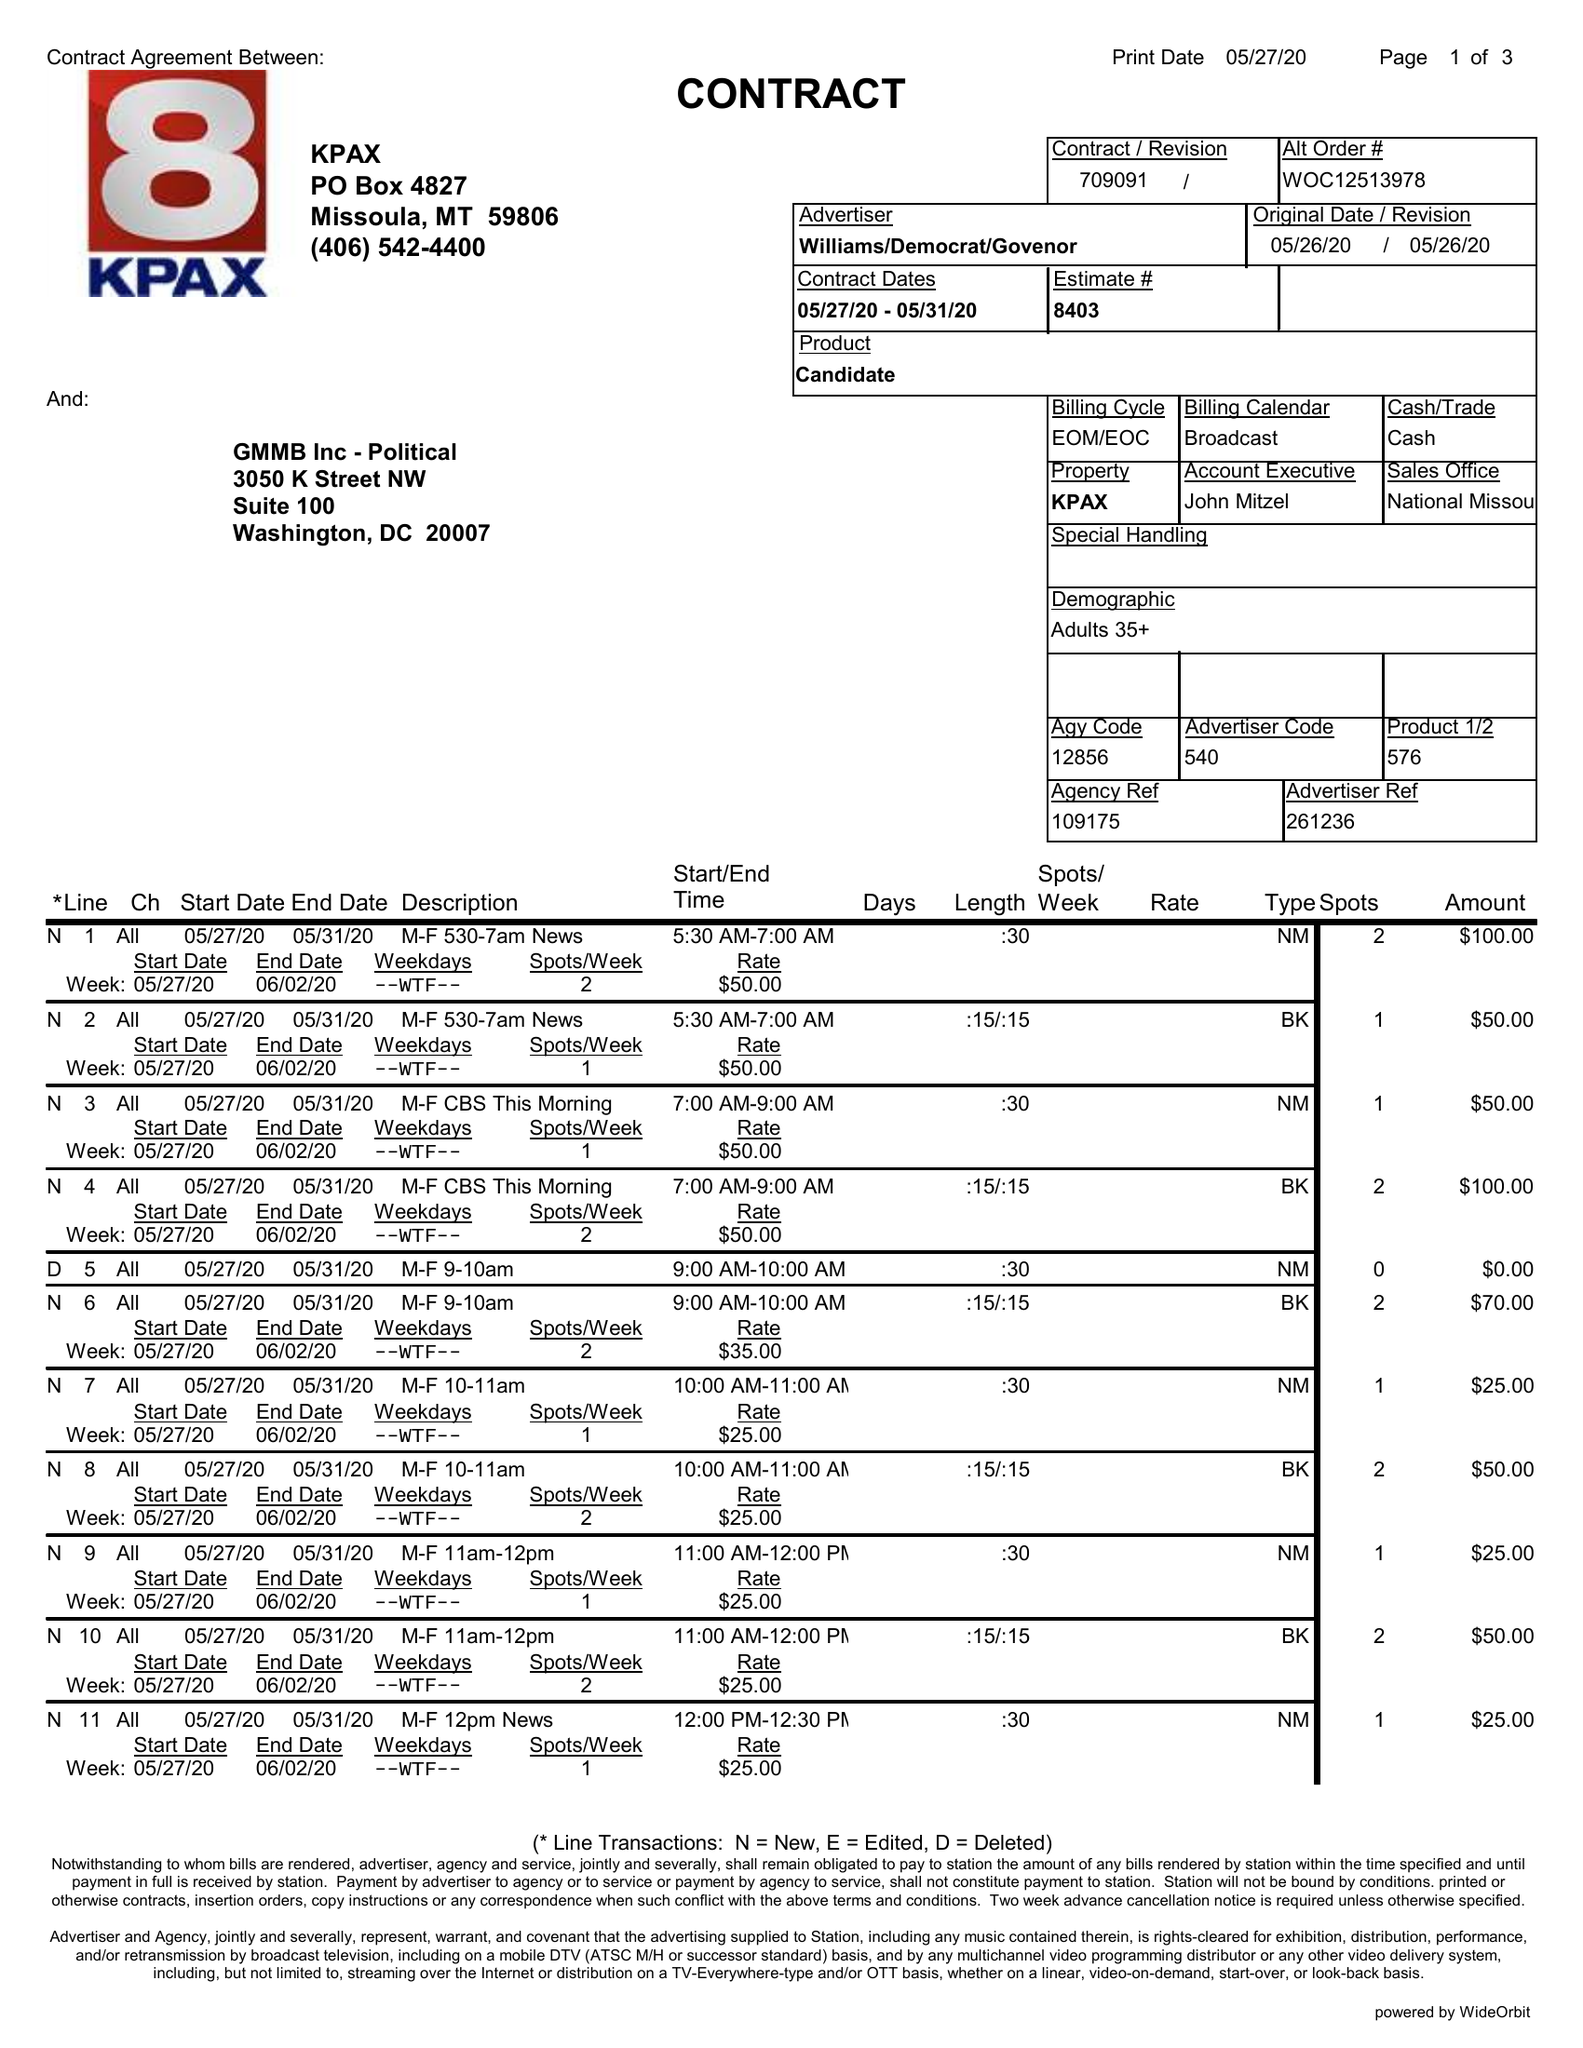What is the value for the contract_num?
Answer the question using a single word or phrase. 709091 